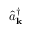<formula> <loc_0><loc_0><loc_500><loc_500>\hat { a } _ { k } ^ { \dagger }</formula> 